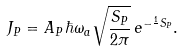<formula> <loc_0><loc_0><loc_500><loc_500>J _ { P } = A _ { P } \, \hbar { \omega } _ { a } \sqrt { \frac { S _ { P } } { 2 \pi } } \, e ^ { - \frac { 1 } { } S _ { P } } .</formula> 